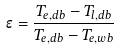<formula> <loc_0><loc_0><loc_500><loc_500>\epsilon = \frac { T _ { e , d b } - T _ { l , d b } } { T _ { e , d b } - T _ { e , w b } }</formula> 